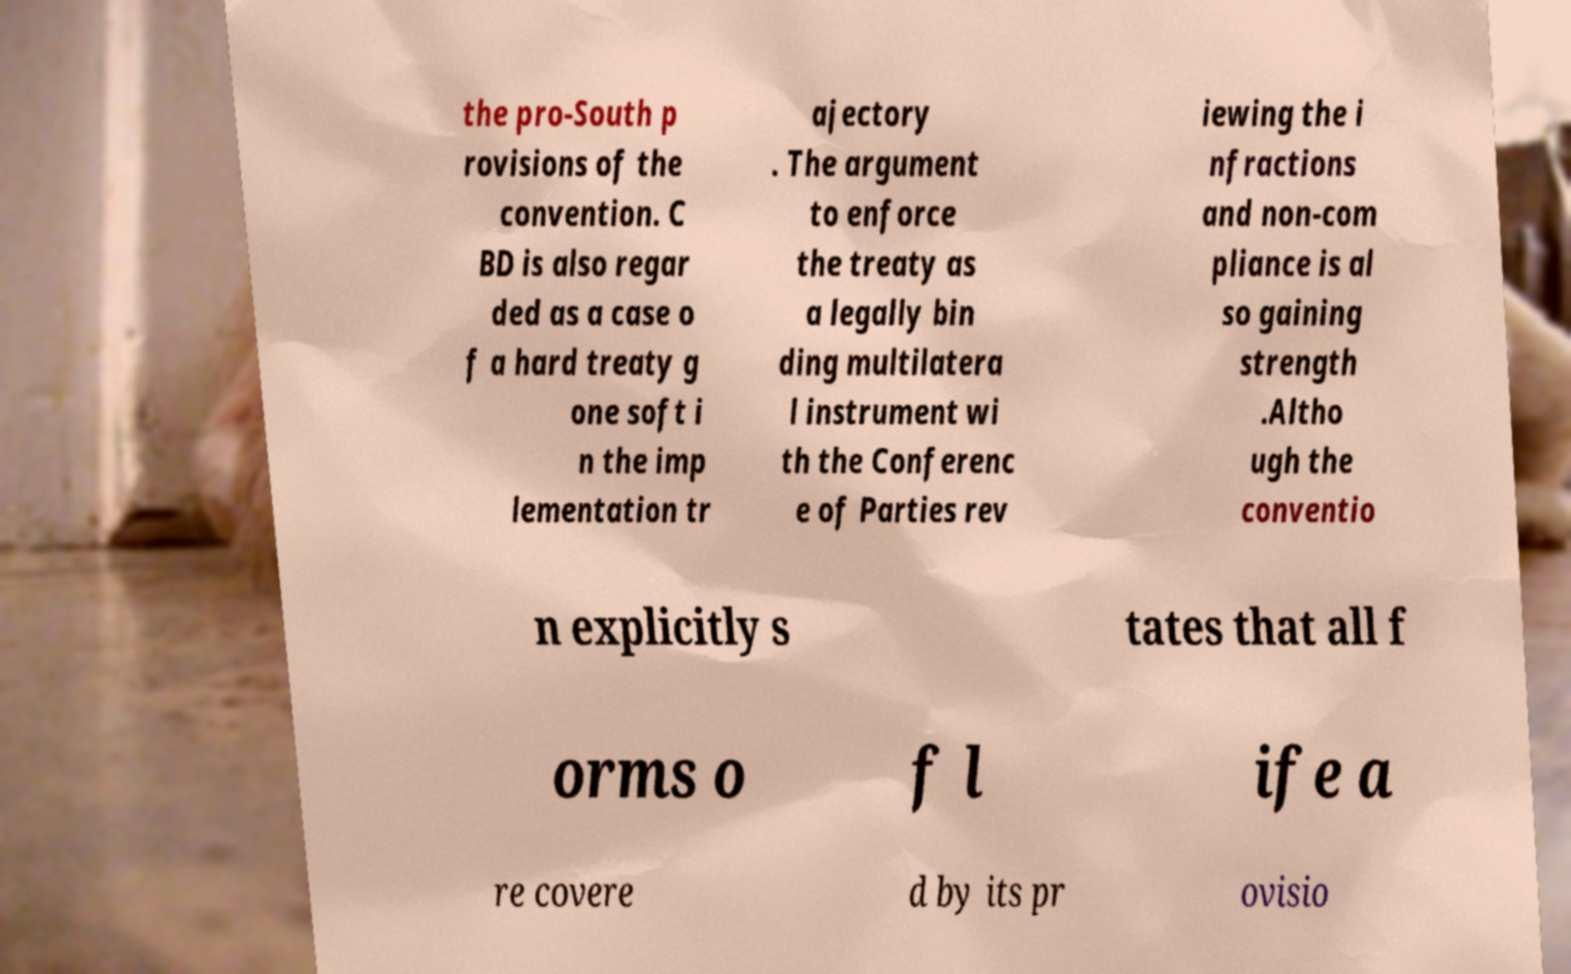Can you accurately transcribe the text from the provided image for me? the pro-South p rovisions of the convention. C BD is also regar ded as a case o f a hard treaty g one soft i n the imp lementation tr ajectory . The argument to enforce the treaty as a legally bin ding multilatera l instrument wi th the Conferenc e of Parties rev iewing the i nfractions and non-com pliance is al so gaining strength .Altho ugh the conventio n explicitly s tates that all f orms o f l ife a re covere d by its pr ovisio 